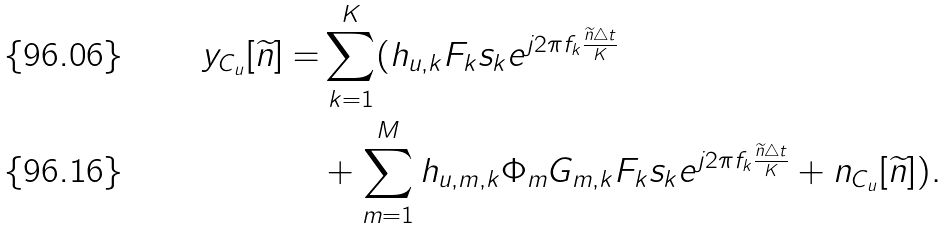<formula> <loc_0><loc_0><loc_500><loc_500>y _ { C _ { u } } [ \widetilde { n } ] = & \sum _ { k = 1 } ^ { K } ( { h } _ { u , k } { F } _ { k } { s } _ { k } e ^ { j 2 \pi { f _ { k } } \frac { \widetilde { n } \triangle t } { K } } \\ & + \sum _ { m = 1 } ^ { M } { h } _ { u , m , k } { \Phi } _ { m } { G } _ { m , k } { F } _ { k } { s } _ { k } e ^ { j 2 \pi { f _ { k } } \frac { \widetilde { n } \triangle t } { K } } + n _ { C _ { u } } [ \widetilde { n } ] ) .</formula> 